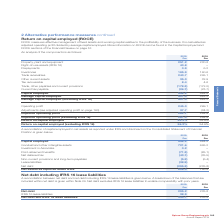According to Spirax Sarco Engineering Plc's financial document, What does net debt exclude? IFRS 16 lease liabilities to enable comparability with prior years. The document states: "t debt is given within Note 24. Net debt excludes IFRS 16 lease liabilities to enable comparability with prior years...." Also, Where is the breakdown of the balances that are included within net debt given? According to the financial document, within Note 24. The relevant text states: "lances that are included within net debt is given within Note 24. Net debt excludes IFRS 16 lease liabilities to enable comparability with prior years...." Also, What is the Net debt and IFRS 16 lease liabilities for 2018 and 2019 respectively? The document shows two values: 235.8 and 334.1 (in millions). From the document: "ies 38.9 – Net debt and IFRS 16 lease liabilities 334.1 235.8 Net debt 295.2 235.8 IFRS 16 lease liabilities 38.9 – Net debt and IFRS 16 lease liabili..." Additionally, In which year is the amount of net debt larger? According to the financial document, 2019. The relevant text states: "Annual Report 2019..." Also, can you calculate: What was the change in the amount of Net debt and IFRS 16 lease liabilities from 2018 to 2019? Based on the calculation: 334.1-235.8, the result is 98.3 (in millions). This is based on the information: "ies 38.9 – Net debt and IFRS 16 lease liabilities 334.1 235.8 Net debt 295.2 235.8 IFRS 16 lease liabilities 38.9 – Net debt and IFRS 16 lease liabilities 334.1 235.8..." The key data points involved are: 235.8, 334.1. Also, can you calculate: What was the percentage change in the amount of Net debt and IFRS 16 lease liabilities from 2018 to 2019? To answer this question, I need to perform calculations using the financial data. The calculation is: (334.1-235.8)/235.8, which equals 41.69 (percentage). This is based on the information: "ies 38.9 – Net debt and IFRS 16 lease liabilities 334.1 235.8 Net debt 295.2 235.8 IFRS 16 lease liabilities 38.9 – Net debt and IFRS 16 lease liabilities 334.1 235.8..." The key data points involved are: 235.8, 334.1. 